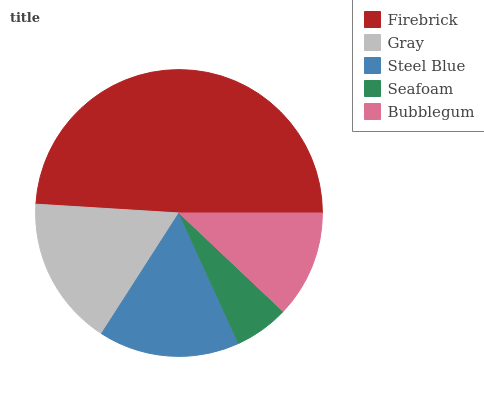Is Seafoam the minimum?
Answer yes or no. Yes. Is Firebrick the maximum?
Answer yes or no. Yes. Is Gray the minimum?
Answer yes or no. No. Is Gray the maximum?
Answer yes or no. No. Is Firebrick greater than Gray?
Answer yes or no. Yes. Is Gray less than Firebrick?
Answer yes or no. Yes. Is Gray greater than Firebrick?
Answer yes or no. No. Is Firebrick less than Gray?
Answer yes or no. No. Is Steel Blue the high median?
Answer yes or no. Yes. Is Steel Blue the low median?
Answer yes or no. Yes. Is Gray the high median?
Answer yes or no. No. Is Seafoam the low median?
Answer yes or no. No. 